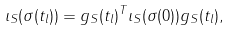Convert formula to latex. <formula><loc_0><loc_0><loc_500><loc_500>\iota _ { S } ( \sigma ( t _ { l } ) ) = g _ { S } ( t _ { l } ) ^ { T } \iota _ { S } ( \sigma ( 0 ) ) g _ { S } ( t _ { l } ) ,</formula> 